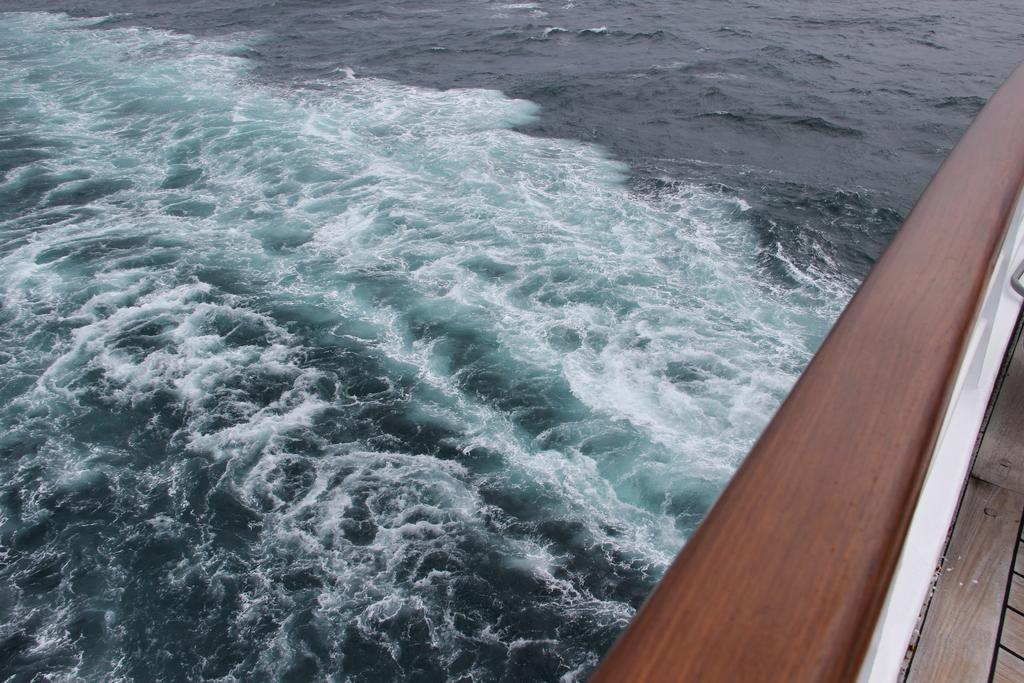What is the main subject of the image? The main subject of the image is a ship. Where is the ship located in the image? The ship is sailing on a river. Can you describe the environment in which the ship is located? The ship is sailing on a river, which suggests a natural setting. How much money is the ship carrying in the image? There is no information about the ship's cargo or the amount of money it might be carrying in the image. 